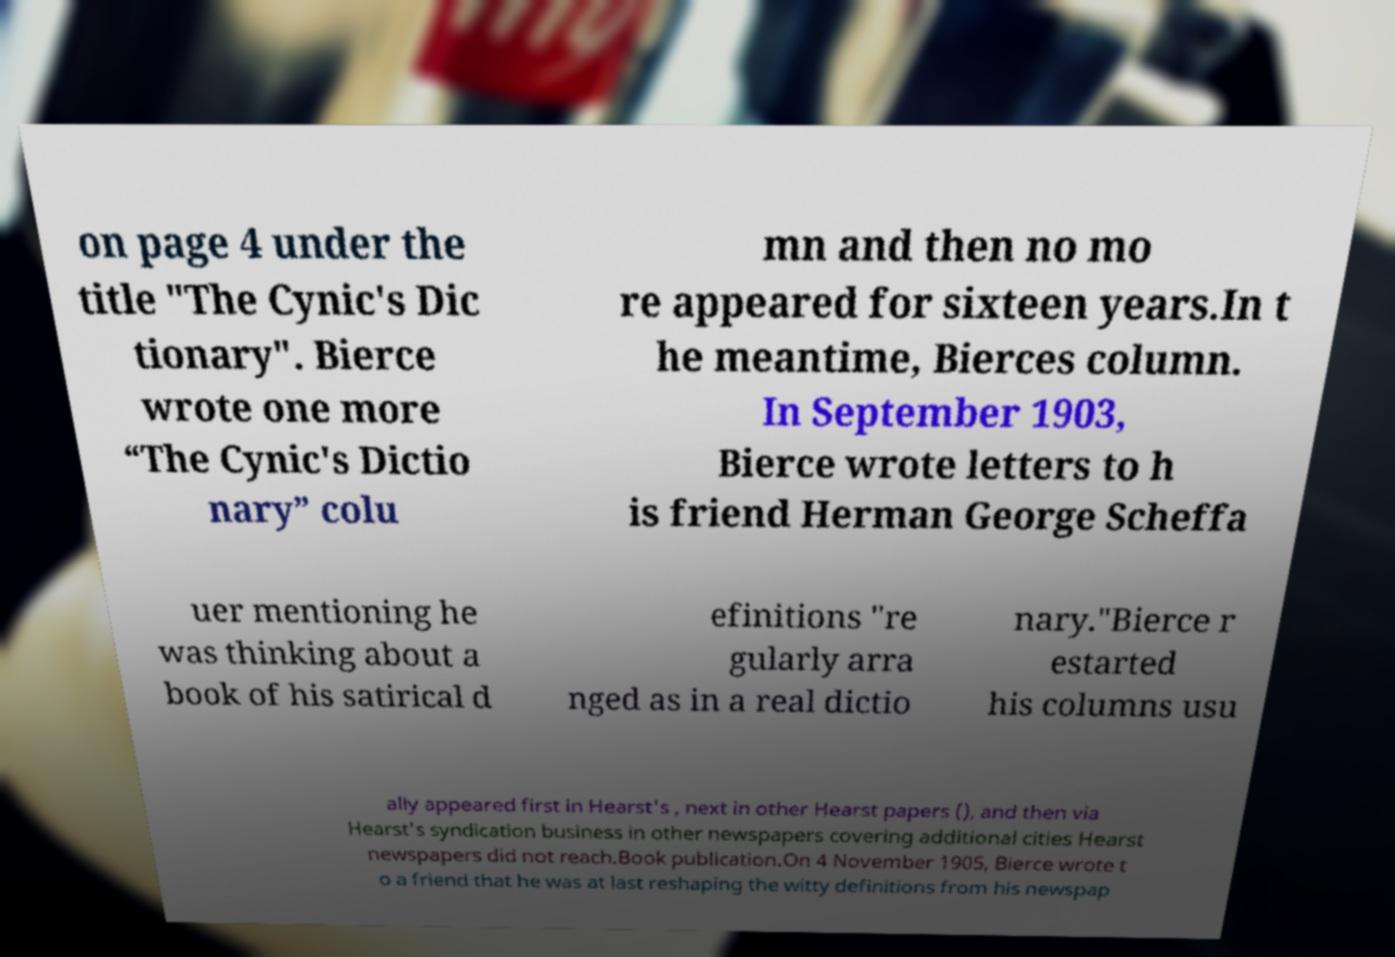What messages or text are displayed in this image? I need them in a readable, typed format. on page 4 under the title "The Cynic's Dic tionary". Bierce wrote one more “The Cynic's Dictio nary” colu mn and then no mo re appeared for sixteen years.In t he meantime, Bierces column. In September 1903, Bierce wrote letters to h is friend Herman George Scheffa uer mentioning he was thinking about a book of his satirical d efinitions "re gularly arra nged as in a real dictio nary."Bierce r estarted his columns usu ally appeared first in Hearst's , next in other Hearst papers (), and then via Hearst's syndication business in other newspapers covering additional cities Hearst newspapers did not reach.Book publication.On 4 November 1905, Bierce wrote t o a friend that he was at last reshaping the witty definitions from his newspap 